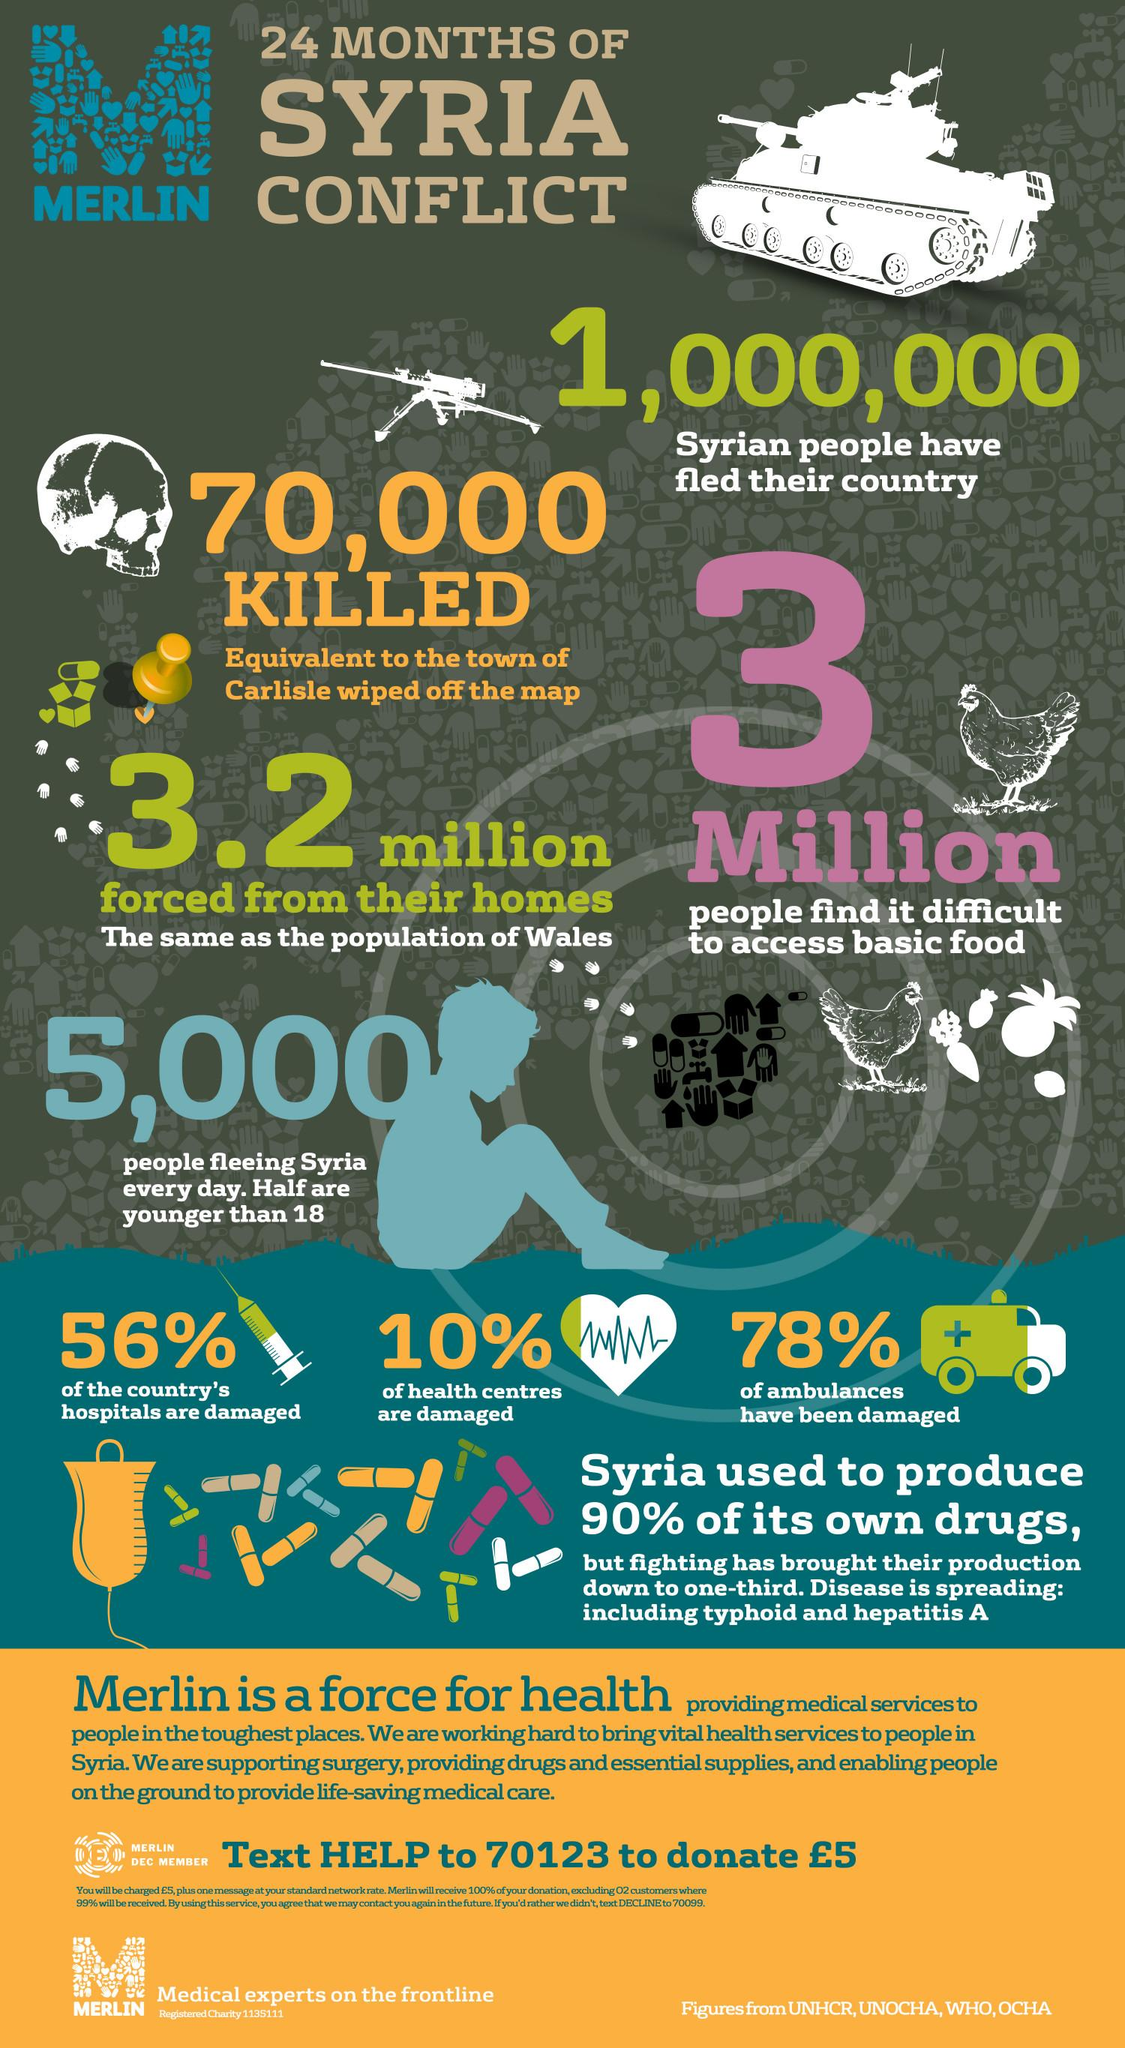Highlight a few significant elements in this photo. Out of all of the health centers in Syria, 90% of them were not significantly damaged during the conflict. In the 24 months of conflict, an estimated 70,000 Syrians lost their lives. It is estimated that over 1,000,000 Syrians have left their country as a result of the ongoing conflict. According to recent estimates, approximately 44% of the country's hospitals were not significantly damaged during the Syrian conflict. During the Syrian conflict, it is estimated that approximately 3 million people are struggling to access basic food supplies, indicating that a significant portion of the population is facing food insecurity. 